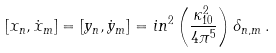<formula> <loc_0><loc_0><loc_500><loc_500>[ x _ { n } , \dot { x } _ { m } ] = [ y _ { n } , \dot { y } _ { m } ] = i n ^ { 2 } \left ( \frac { \kappa _ { 1 0 } ^ { 2 } } { 4 \pi ^ { 5 } } \right ) \delta _ { n , m } \, .</formula> 